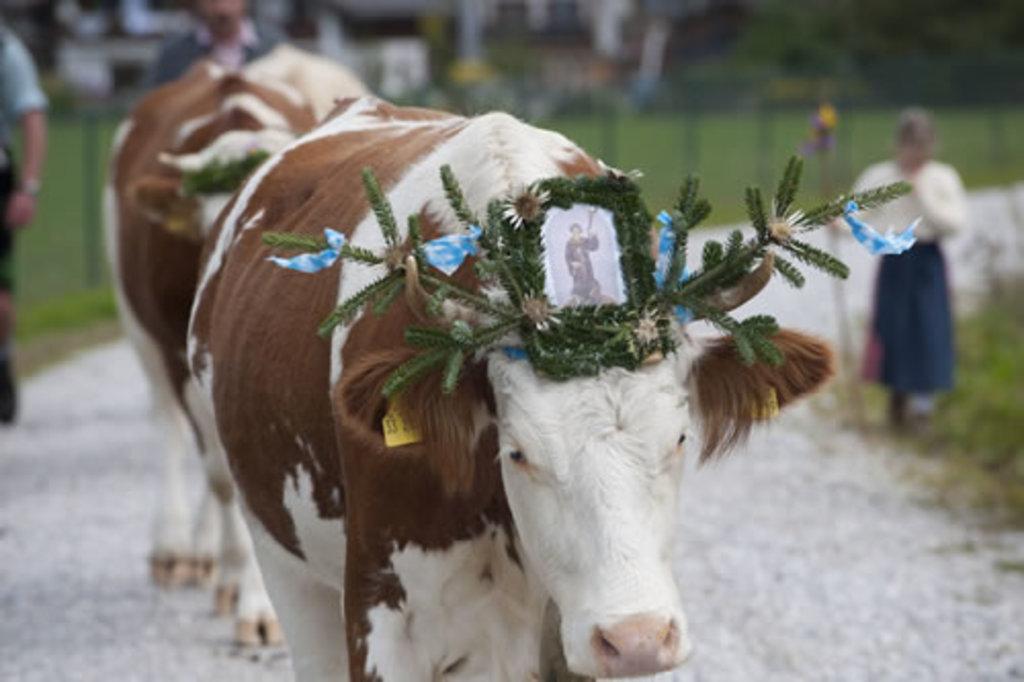Can you describe this image briefly? In this image, we can see a cow with some decorative object and photo. Background there is a blur view. Here we can see cow, few people walkway, poles. 